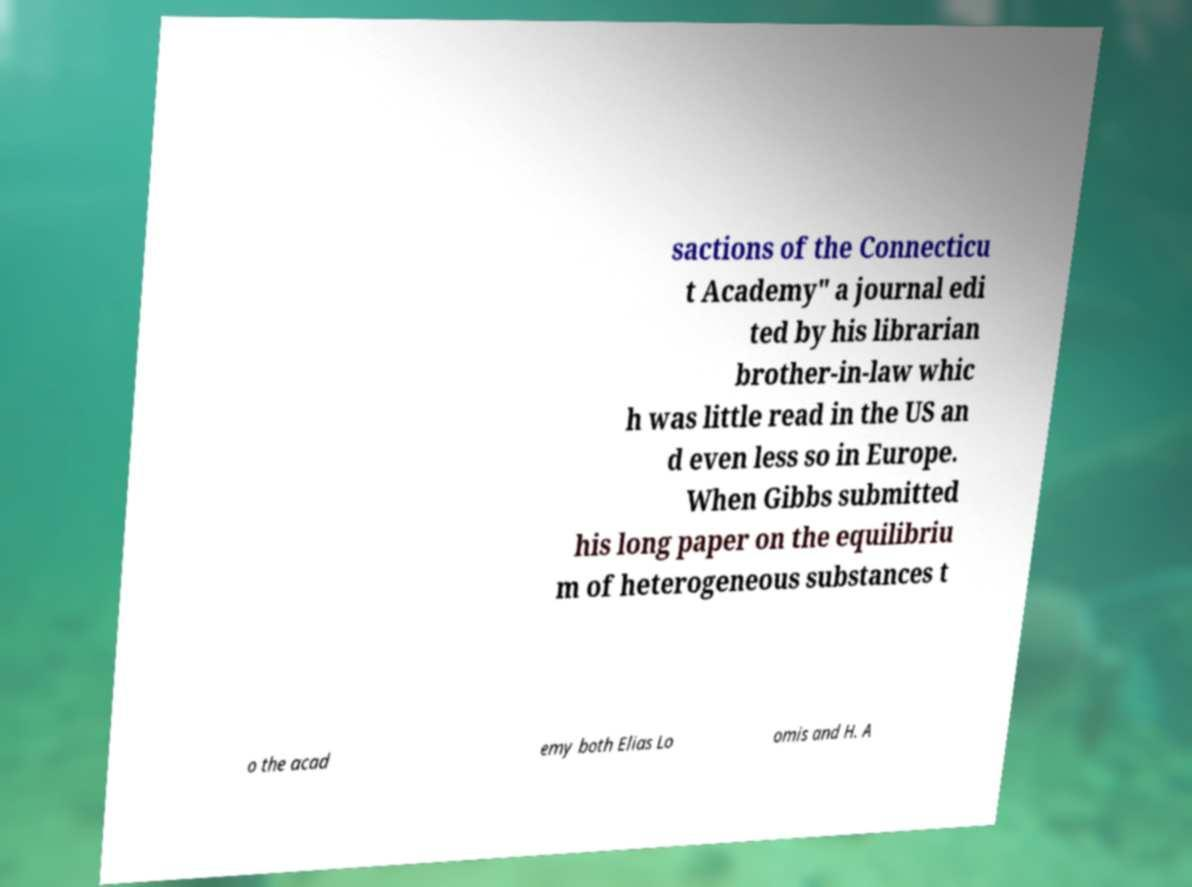Can you read and provide the text displayed in the image?This photo seems to have some interesting text. Can you extract and type it out for me? sactions of the Connecticu t Academy" a journal edi ted by his librarian brother-in-law whic h was little read in the US an d even less so in Europe. When Gibbs submitted his long paper on the equilibriu m of heterogeneous substances t o the acad emy both Elias Lo omis and H. A 